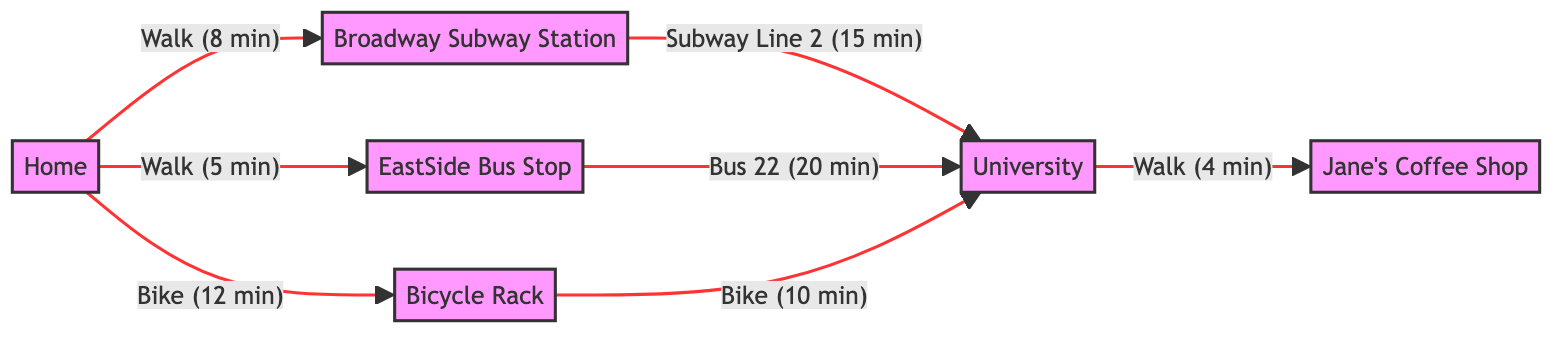What is the travel time from Home to the Broadway Subway Station? The edge from Home to the Broadway Subway Station indicates a travel time of 8 minutes for the Walk method.
Answer: 8 minutes What method is used to travel from the EastSide Bus Stop to the University? The edge from the EastSide Bus Stop to the University specifies the method as Bus 22.
Answer: Bus 22 How many nodes are present in the diagram? The diagram lists six unique locations: Home, University, Broadway Subway Station, EastSide Bus Stop, Jane's Coffee Shop, and Bicycle Rack. This totals to six nodes.
Answer: 6 What is the total travel time from Home to the University using the subway? The travel time consists of walking to the Broadway Subway Station (8 minutes) and then riding Subway Line 2 to the University (15 minutes). Adding these gives a total of 23 minutes.
Answer: 23 minutes If someone bikes to the Bicycle Rack first, what is the total travel time to the University from there? First, they bike from Home to the Bicycle Rack (12 minutes), and then they bike from the Bicycle Rack to the University (10 minutes). This sums up to 22 minutes in total.
Answer: 22 minutes What is the shortest travel time from Home to the University? To calculate the shortest route, one can compare the paths: Walking to the bus stop (5 minutes) and then taking the Bus 22 to the University (20 minutes) totals 25 minutes. However, using the subway (8 minutes + 15 minutes) gives a total of 23 minutes, which is shorter.
Answer: 23 minutes What are the locations directly connected to the University? The University is connected to three locations based on the edges: the Broadway Subway Station, the EastSide Bus Stop, and the Bicycle Rack, and it also connects to Jane's Coffee Shop.
Answer: Broadway Subway Station, EastSide Bus Stop, Bicycle Rack, Jane's Coffee Shop Which location is the farthest from Home based on the time taken to reach the University? Based on the travel methods indicated, the bus route from Home to University through the EastSide Bus Stop (5 minutes to Bus Stop and then 20 minutes on Bus 22) totals up to 25 minutes which is longer than the subway route. The Bicycle Rack also has a combined total time of 22 minutes only if you include extra biking time to get to the Bicycle Rack.
Answer: EastSide Bus Stop 